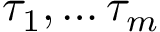<formula> <loc_0><loc_0><loc_500><loc_500>\tau _ { 1 } , \dots \tau _ { m }</formula> 